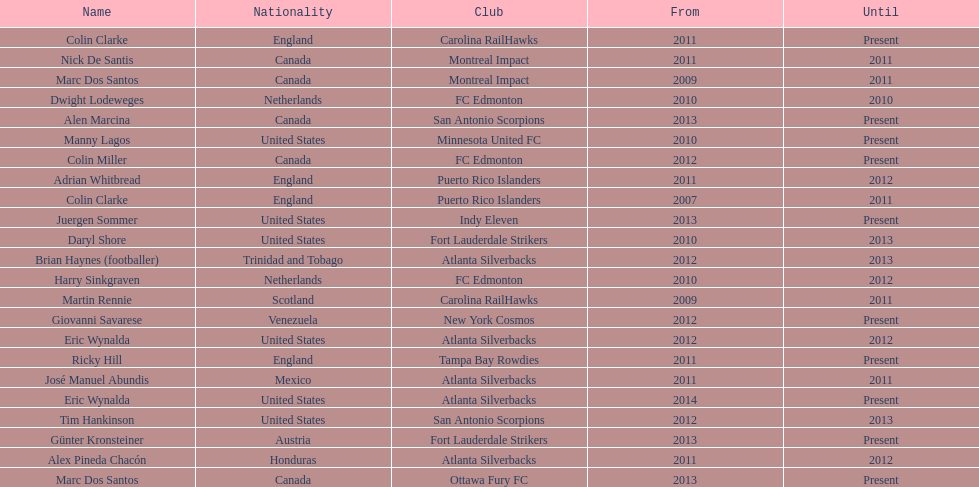What same country did marc dos santos coach as colin miller? Canada. 